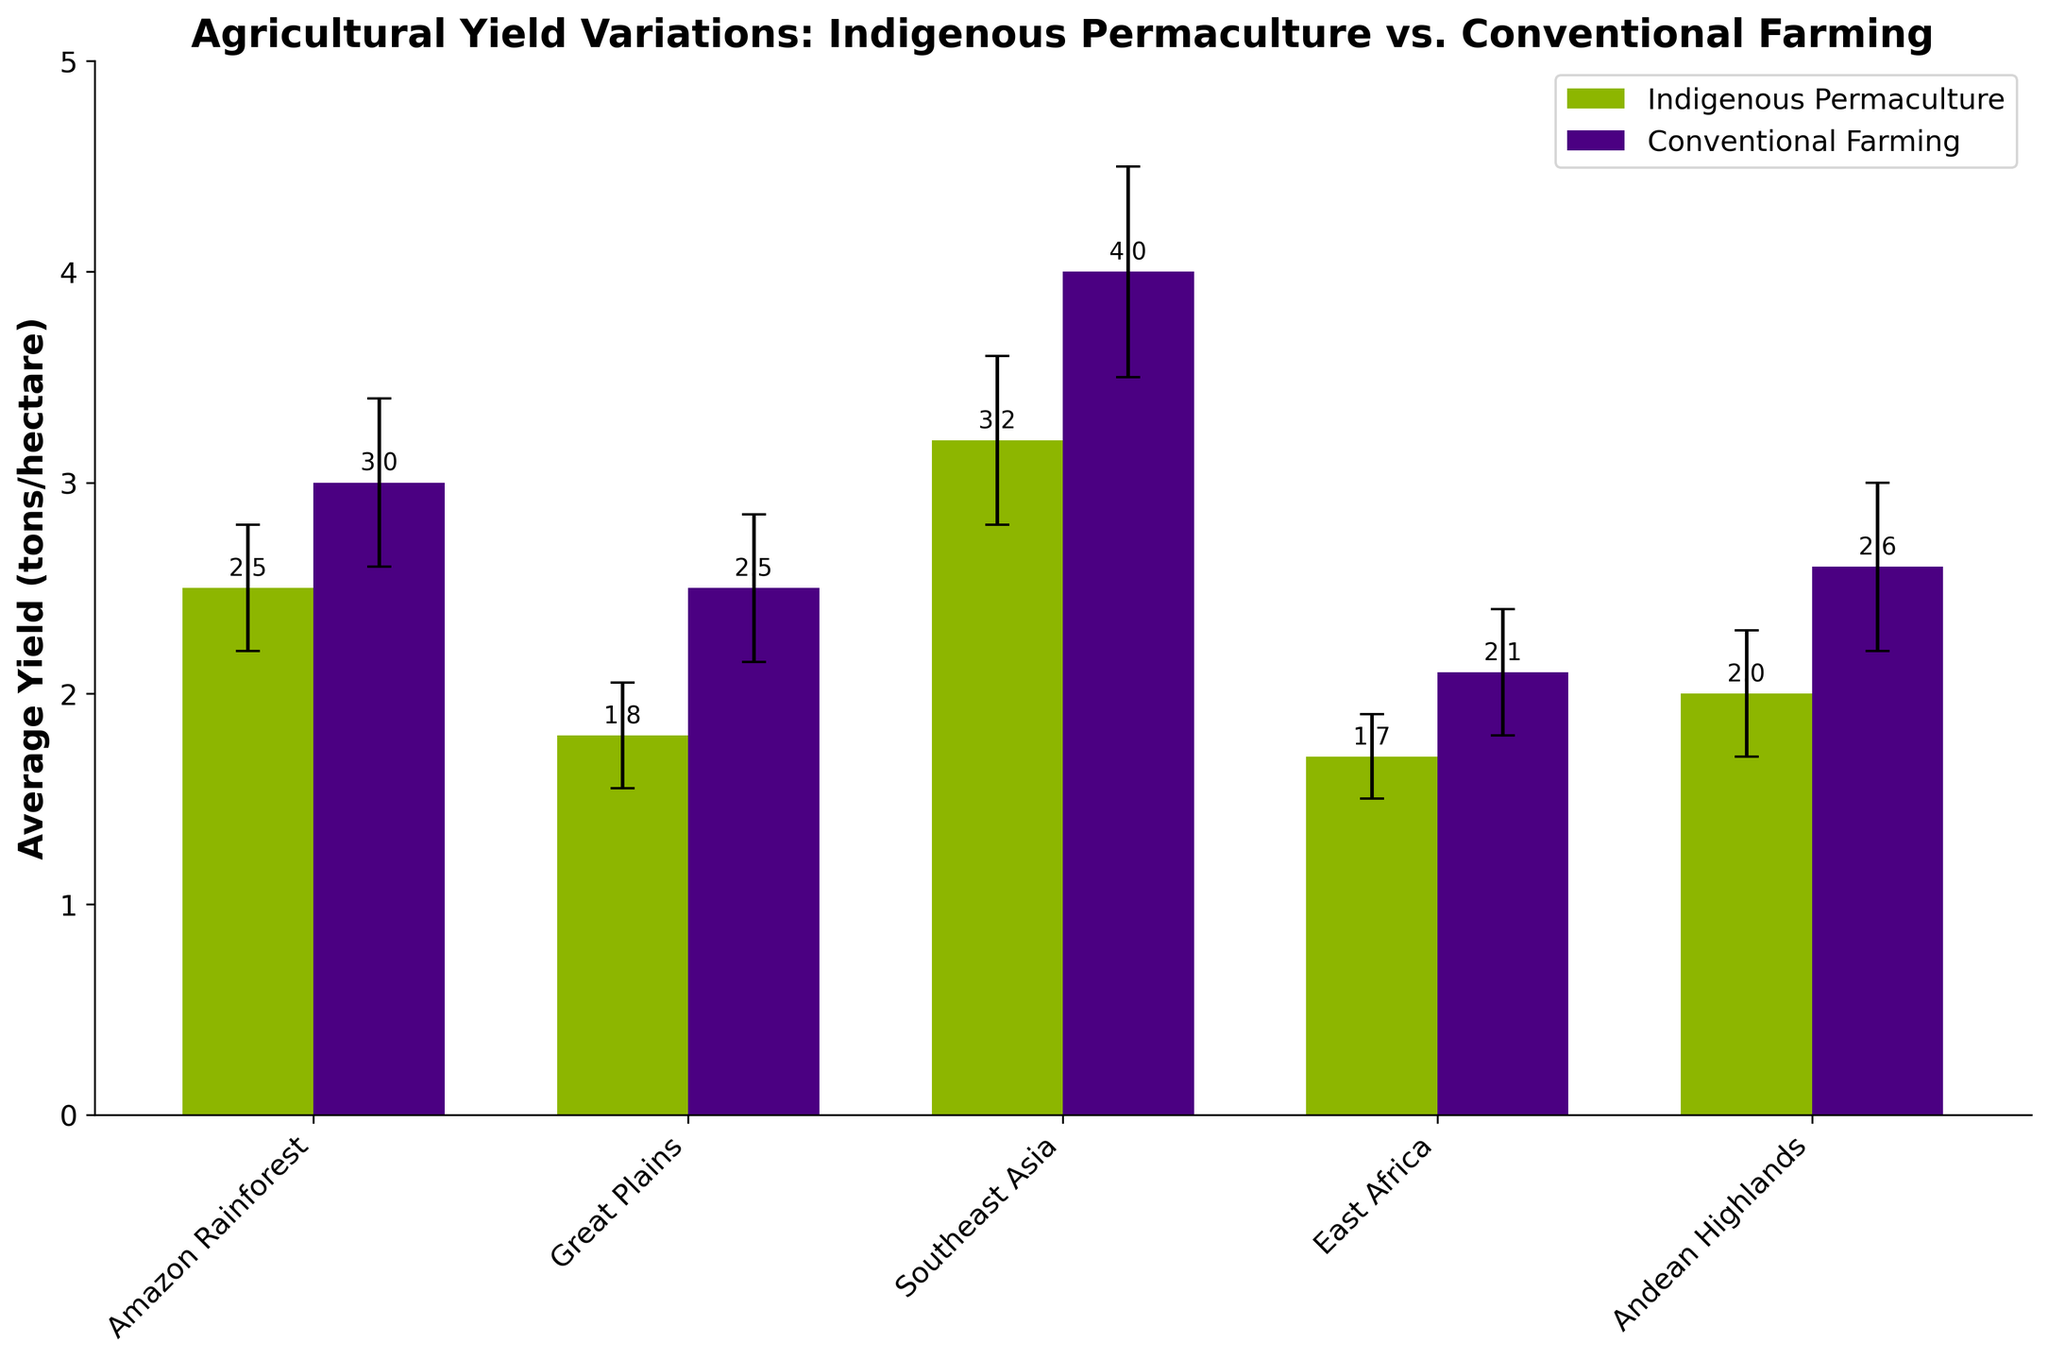what is the title of the figure? The title is usually located at the top of the figure and is meant to provide a concise description of the content.
Answer: Agricultural Yield Variations: Indigenous Permaculture vs. Conventional Farming Is the yield higher for conventional farming or indigenous permaculture in the Amazon Rainforest? By looking at the bar heights for both methods in the Amazon Rainforest, the bar for conventional farming is higher.
Answer: Conventional Farming What is the average yield range (mean ± error) for indigenous permaculture in the Great Plains? The average yield is 1.8 tons/hectare with an error margin of ±0.25. Adding and subtracting the error gives the range.
Answer: 1.55 to 2.05 tons/hectare Which region shows the smallest difference in yield between the two farming methods? By calculating and comparing the difference between yields for each region, the Andean Highlands show the smallest difference (2.6 - 2.0 = 0.6).
Answer: Andean Highlands How much higher is the yield for indigenous permaculture in Southeast Asia compared to the Great Plains? Subtract the average yield of indigenous permaculture in the Great Plains from that in Southeast Asia (3.2 - 1.8).
Answer: 1.4 tons/hectare What is the approximate visual ratio of the yield between conventional farming and indigenous permaculture in East Africa? By comparing the bar heights visually, the yield for conventional farming is roughly 1.25 times higher than indigenous permaculture (2.1/1.7 is approximately 1.24).
Answer: 1.25 times Are the error bars larger for conventional farming or indigenous permaculture across all regions? By visually comparing the size of the error bars between the two methods across all regions, conventional farming consistently has larger error bars.
Answer: Conventional Farming What's the combined average yield for indigenous permaculture across all regions? Add the average yields for indigenous permaculture across all regions (2.5 + 1.8 + 3.2 + 1.7 + 2.0) and divide by the number of regions (5). (2.5 + 1.8 + 3.2 + 1.7 + 2.0) / 5 = 11.2 / 5.
Answer: 2.24 tons/hectare 